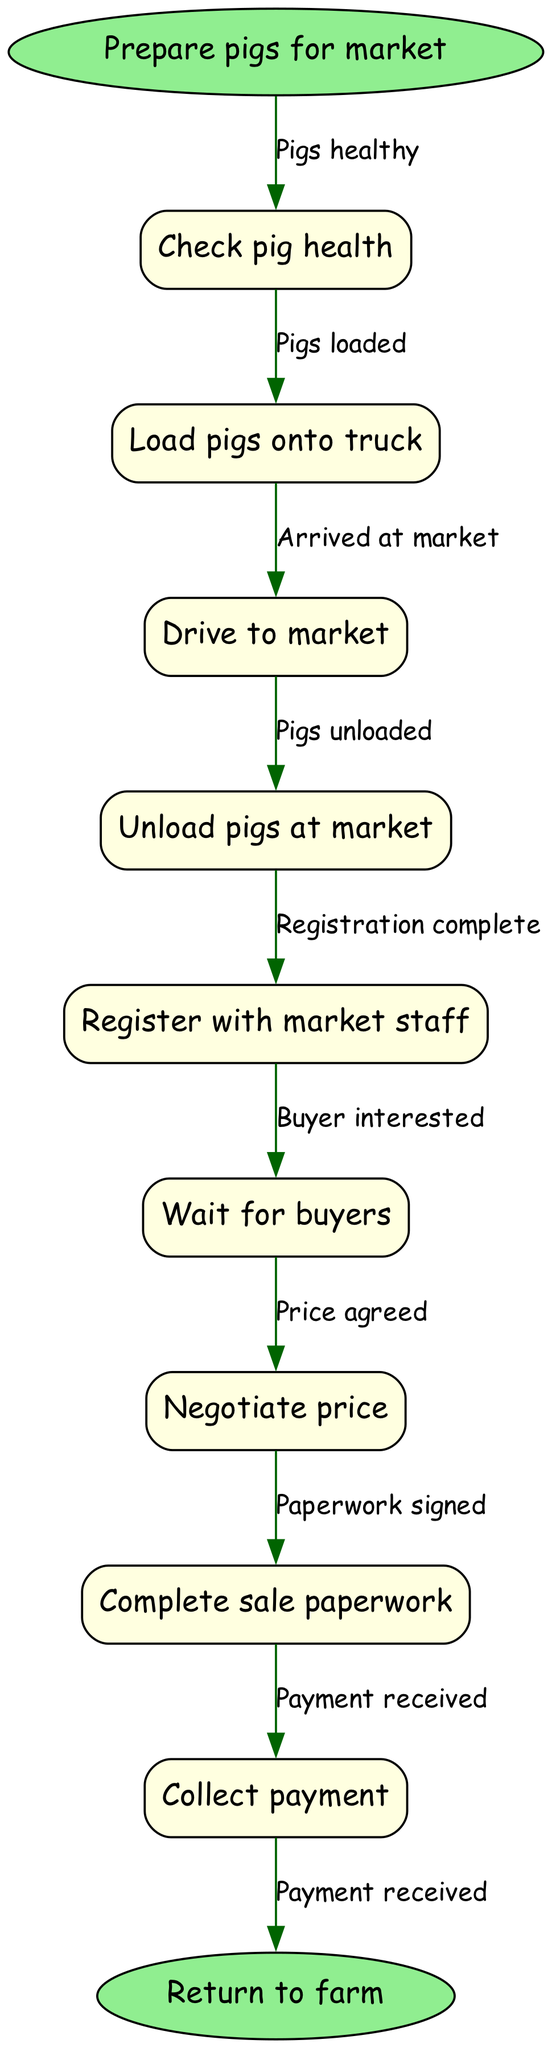What is the first step in the process? The first step in the process is "Prepare pigs for market", which is indicated as the starting point of the flowchart.
Answer: Prepare pigs for market How many nodes are in the diagram? The total number of nodes can be counted as one for the start node, plus the nodes representing each step in the process, and one for the end node, thus there are 10 nodes in total (1 start + 8 process + 1 end).
Answer: 10 What is the final step before returning to the farm? The last step before returning to the farm is "Collect payment", located at the second-to-last position in the flowchart.
Answer: Collect payment Which node comes after "Drive to market"? The node that comes after "Drive to market" is "Unload pigs at market", demonstrating the sequence of actions.
Answer: Unload pigs at market What is required before you can unload pigs? Before unloading pigs, you must have "Arrived at market", as indicated by the edge that connects the relevant nodes in the flow.
Answer: Arrived at market Which action happens if a buyer is interested? If a buyer is interested, the next action is "Negotiate price", indicating the flow from interest to agreement on terms.
Answer: Negotiate price What is the relationship between "Check pig health" and "Load pigs onto truck"? The relationship is sequential; after confirming that "Pigs healthy" from checking health, you proceed to "Load pigs onto truck".
Answer: Pigs healthy How many edges are in the diagram? The number of edges can be determined by counting the connections between the nodes, which totals 9 edges (one for each transition between the 9 nodes).
Answer: 9 